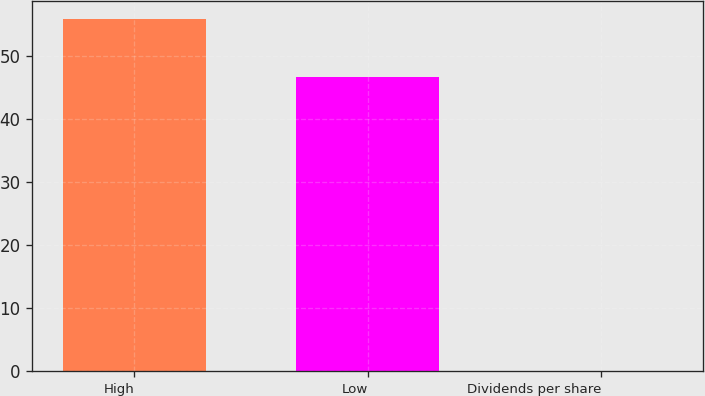Convert chart. <chart><loc_0><loc_0><loc_500><loc_500><bar_chart><fcel>High<fcel>Low<fcel>Dividends per share<nl><fcel>55.87<fcel>46.75<fcel>0.1<nl></chart> 